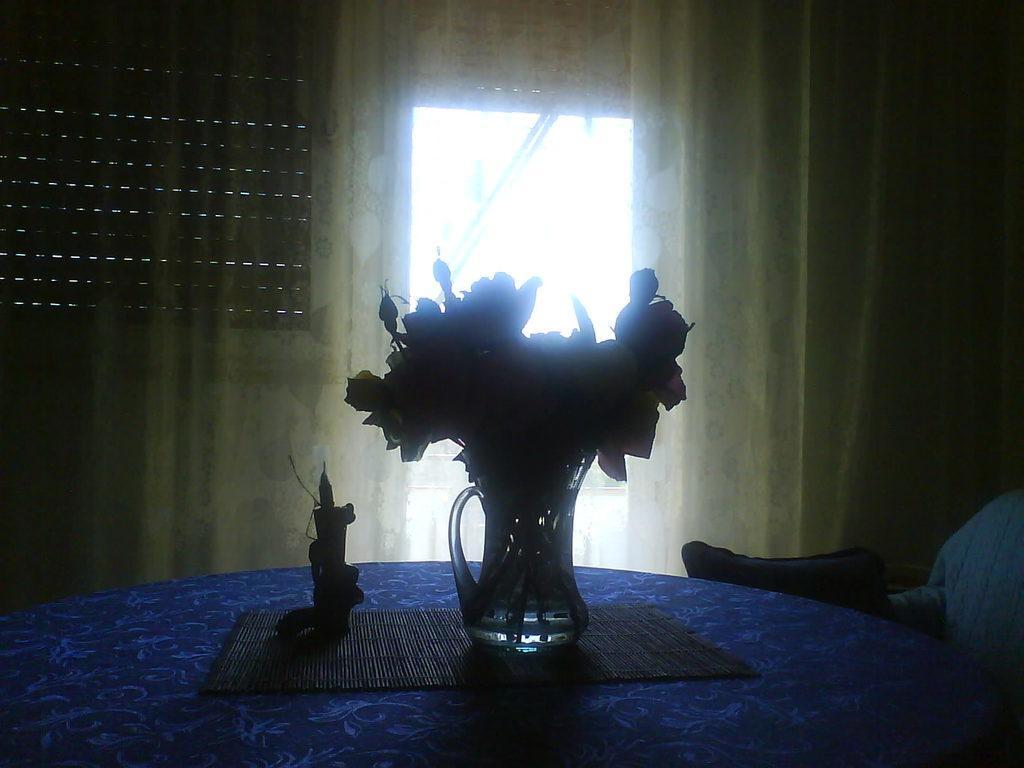In one or two sentences, can you explain what this image depicts? In this image we can see a table. On the table there are decors placed on the mat. In the background we can see curtains, window and a pillow on the chair. 